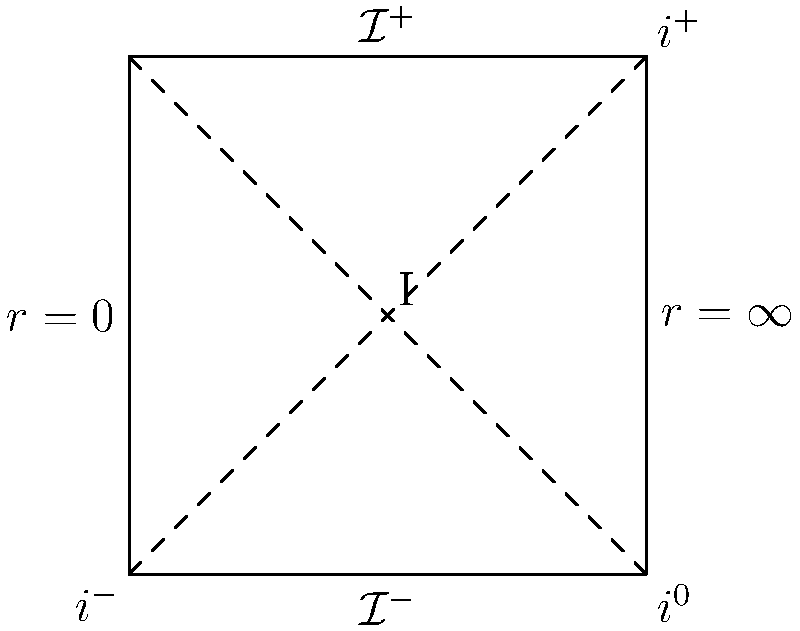In the Penrose diagram of Minkowski spacetime shown above, what does the point labeled "I" represent, and why is its position significant in the context of causal structure? To understand the significance of point "I" in the Penrose diagram, let's follow these steps:

1. Penrose diagrams are conformal representations of spacetime that bring infinity to a finite distance. This allows us to visualize the causal structure of the entire spacetime in a finite diagram.

2. In this diagram:
   - The vertical axis represents time
   - The horizontal axis represents radial distance
   - $r=0$ is the origin of spatial coordinates
   - $r=\infty$ represents spatial infinity

3. The boundaries of the diagram represent:
   - $i^+$: Future timelike infinity
   - $i^-$: Past timelike infinity
   - $i^0$: Spatial infinity
   - $\mathcal{I}^+$: Future null infinity
   - $\mathcal{I}^-$: Past null infinity

4. Point "I" is located at the center of the diagram, equidistant from all boundaries.

5. This central position means that light rays (which follow 45-degree lines in a Penrose diagram) starting from "I" will reach all points of $\mathcal{I}^+$ and $i^+$, and light rays from all points of $\mathcal{I}^-$ and $i^-$ can reach "I".

6. In the context of causal structure, this means that:
   - "I" can receive information from the entire past of the spacetime
   - "I" can send information to the entire future of the spacetime

7. Therefore, point "I" represents a special event in spacetime from which the entire future is observable and which can be influenced by the entire past.

8. In Minkowski spacetime, this point corresponds to the origin of coordinates $(t=0, r=0)$ in the original unbounded spacetime before the conformal transformation.
Answer: Point "I" represents the origin $(t=0, r=0)$, with complete causal access to past and future infinity. 